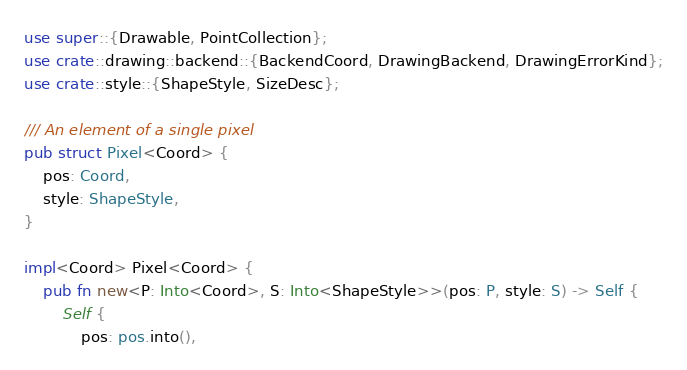<code> <loc_0><loc_0><loc_500><loc_500><_Rust_>use super::{Drawable, PointCollection};
use crate::drawing::backend::{BackendCoord, DrawingBackend, DrawingErrorKind};
use crate::style::{ShapeStyle, SizeDesc};

/// An element of a single pixel
pub struct Pixel<Coord> {
    pos: Coord,
    style: ShapeStyle,
}

impl<Coord> Pixel<Coord> {
    pub fn new<P: Into<Coord>, S: Into<ShapeStyle>>(pos: P, style: S) -> Self {
        Self {
            pos: pos.into(),</code> 